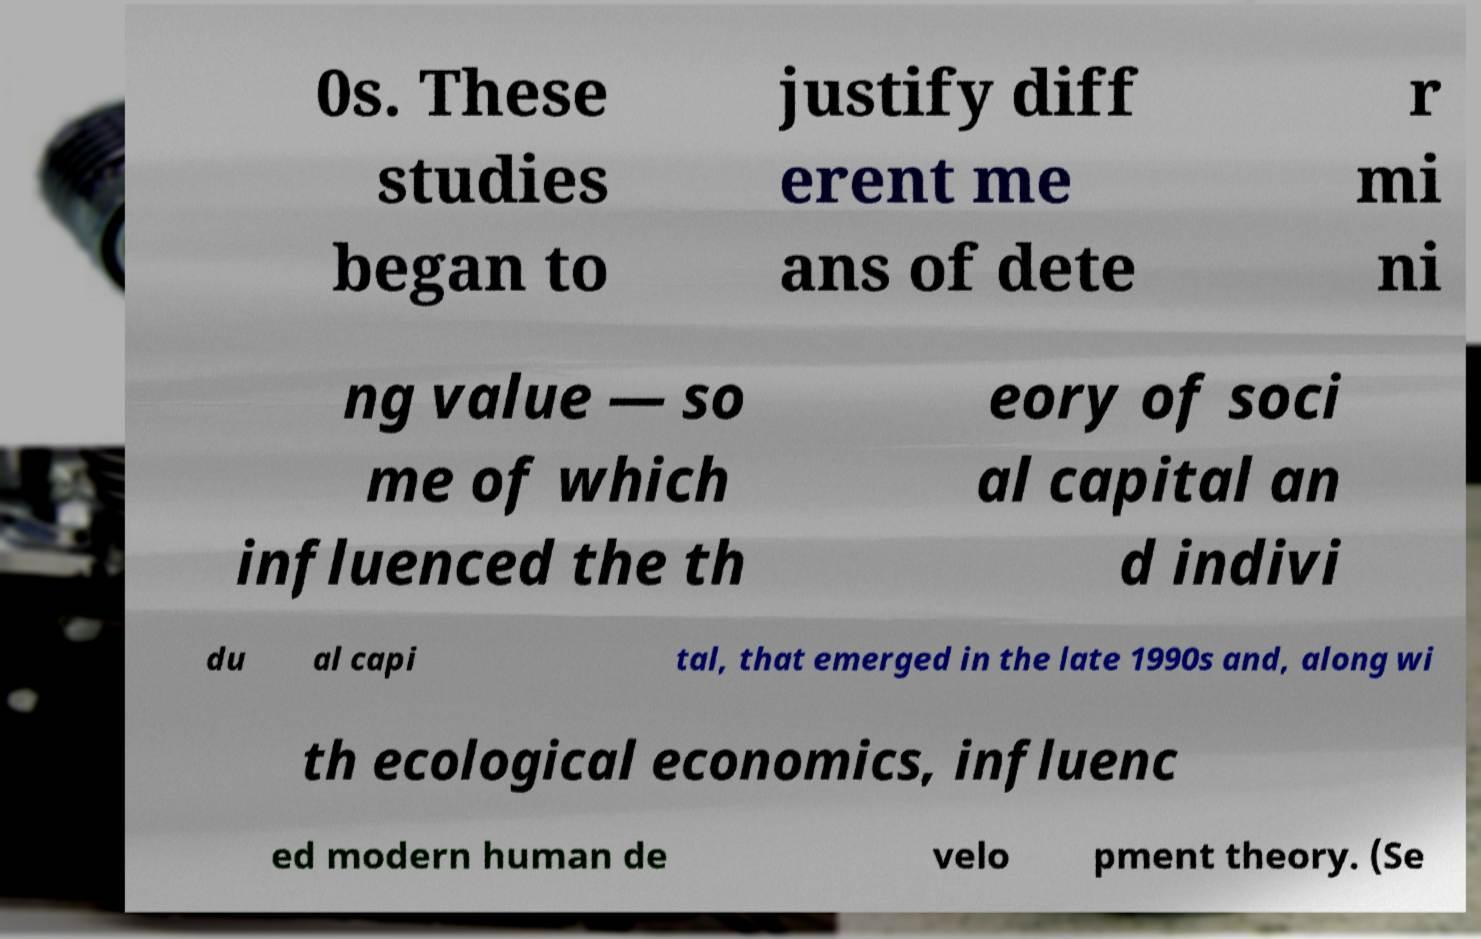There's text embedded in this image that I need extracted. Can you transcribe it verbatim? 0s. These studies began to justify diff erent me ans of dete r mi ni ng value — so me of which influenced the th eory of soci al capital an d indivi du al capi tal, that emerged in the late 1990s and, along wi th ecological economics, influenc ed modern human de velo pment theory. (Se 